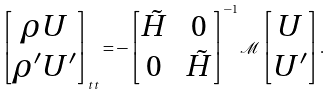Convert formula to latex. <formula><loc_0><loc_0><loc_500><loc_500>\begin{bmatrix} \rho U \\ \rho ^ { \prime } U ^ { \prime } \end{bmatrix} _ { t t } = - \begin{bmatrix} \tilde { H } & 0 \\ 0 & \tilde { H } \end{bmatrix} ^ { - 1 } \mathcal { M } \begin{bmatrix} U \\ U ^ { \prime } \end{bmatrix} .</formula> 